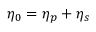Convert formula to latex. <formula><loc_0><loc_0><loc_500><loc_500>\eta _ { 0 } = \eta _ { p } + \eta _ { s }</formula> 